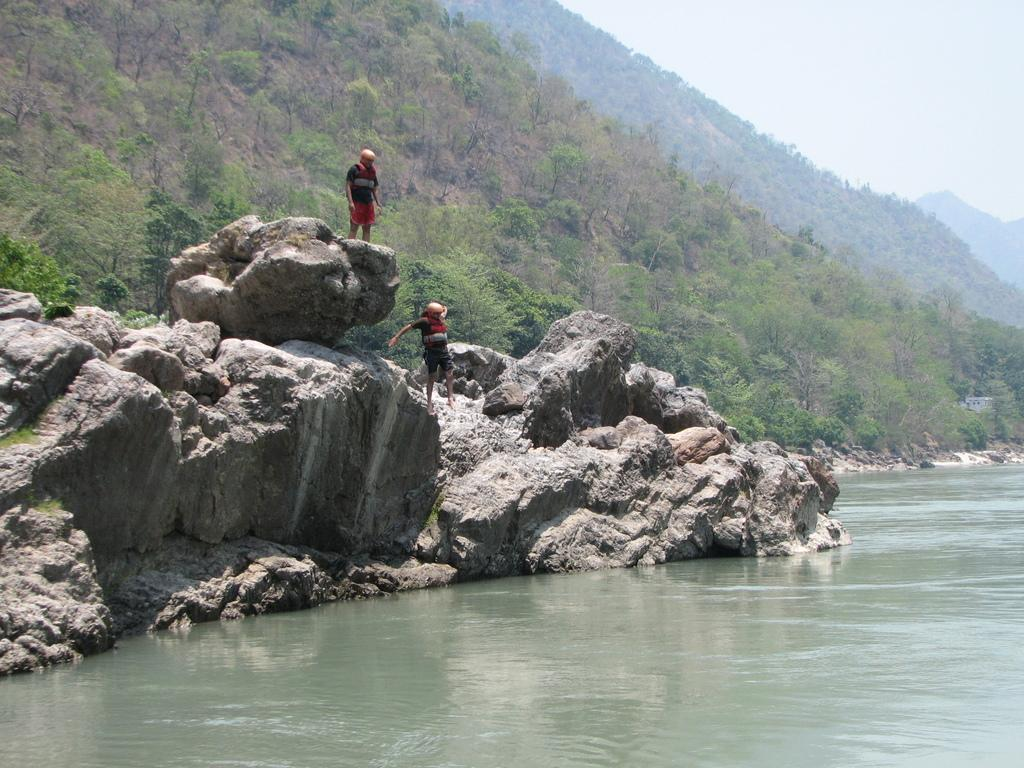How many people are in the image? There are two persons standing on the rocks in the image. What is located on the right side of the image? There is water on the right side of the image. What can be seen in the background of the image? There are trees, mountains, and the sky visible in the background of the image. What type of lace can be seen on the trees in the image? There is no lace present on the trees in the image. What kind of music can be heard playing in the background of the image? There is no music present in the image, as it is a still photograph. 